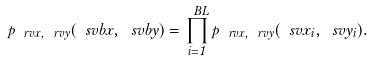Convert formula to latex. <formula><loc_0><loc_0><loc_500><loc_500>p _ { \ r v x , \ r v y } ( \ s v b x , \ s v b y ) = \prod _ { i = 1 } ^ { \ B L } p _ { \ r v x , \ r v y } ( \ s v x _ { i } , \ s v y _ { i } ) .</formula> 